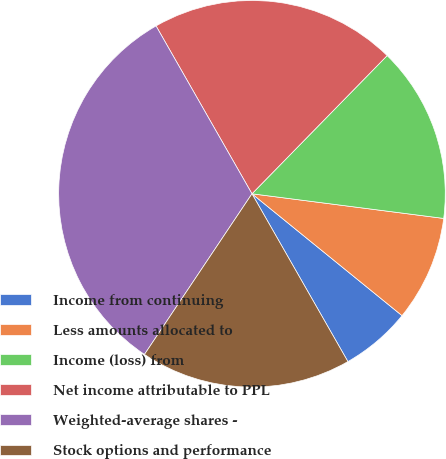Convert chart to OTSL. <chart><loc_0><loc_0><loc_500><loc_500><pie_chart><fcel>Income from continuing<fcel>Less amounts allocated to<fcel>Income (loss) from<fcel>Net income attributable to PPL<fcel>Weighted-average shares -<fcel>Stock options and performance<nl><fcel>5.88%<fcel>8.82%<fcel>14.71%<fcel>20.59%<fcel>32.35%<fcel>17.65%<nl></chart> 